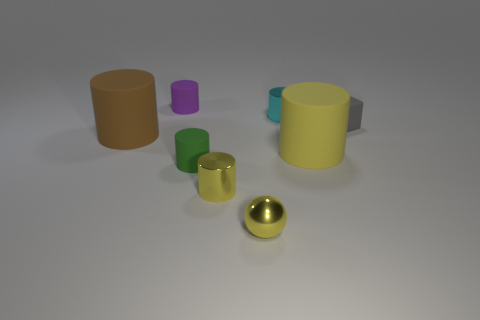There is a matte thing that is left of the purple rubber thing; is its size the same as the large yellow cylinder?
Offer a terse response. Yes. What number of other objects are there of the same shape as the purple object?
Offer a very short reply. 5. What number of green objects are metallic objects or metallic balls?
Your response must be concise. 0. Does the tiny rubber cylinder that is in front of the purple rubber thing have the same color as the small ball?
Keep it short and to the point. No. What is the shape of the purple thing that is the same material as the large brown cylinder?
Offer a very short reply. Cylinder. There is a cylinder that is both on the right side of the sphere and behind the small gray object; what is its color?
Your answer should be compact. Cyan. What size is the yellow object that is to the right of the tiny yellow sphere in front of the large yellow thing?
Keep it short and to the point. Large. Are there any large rubber cylinders that have the same color as the small sphere?
Your answer should be very brief. Yes. Is the number of big yellow rubber things that are to the left of the tiny green matte thing the same as the number of small yellow metal cylinders?
Make the answer very short. No. How many large purple cylinders are there?
Provide a short and direct response. 0. 